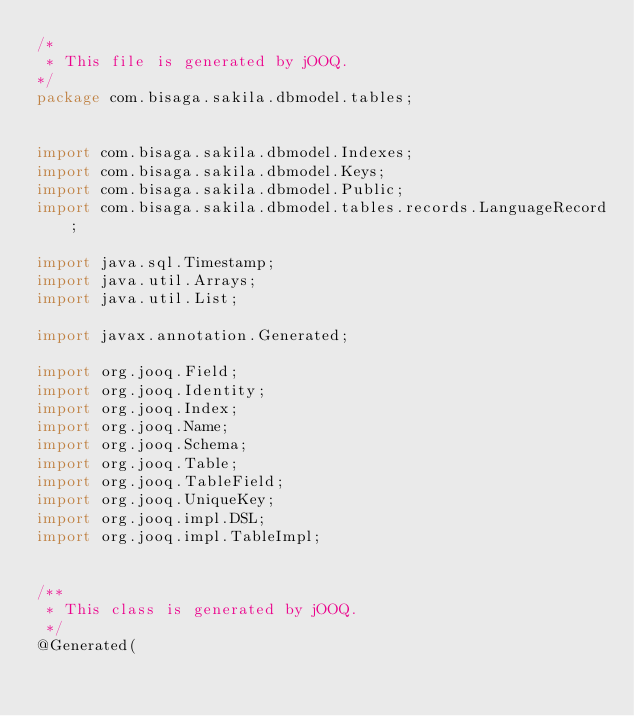Convert code to text. <code><loc_0><loc_0><loc_500><loc_500><_Java_>/*
 * This file is generated by jOOQ.
*/
package com.bisaga.sakila.dbmodel.tables;


import com.bisaga.sakila.dbmodel.Indexes;
import com.bisaga.sakila.dbmodel.Keys;
import com.bisaga.sakila.dbmodel.Public;
import com.bisaga.sakila.dbmodel.tables.records.LanguageRecord;

import java.sql.Timestamp;
import java.util.Arrays;
import java.util.List;

import javax.annotation.Generated;

import org.jooq.Field;
import org.jooq.Identity;
import org.jooq.Index;
import org.jooq.Name;
import org.jooq.Schema;
import org.jooq.Table;
import org.jooq.TableField;
import org.jooq.UniqueKey;
import org.jooq.impl.DSL;
import org.jooq.impl.TableImpl;


/**
 * This class is generated by jOOQ.
 */
@Generated(</code> 